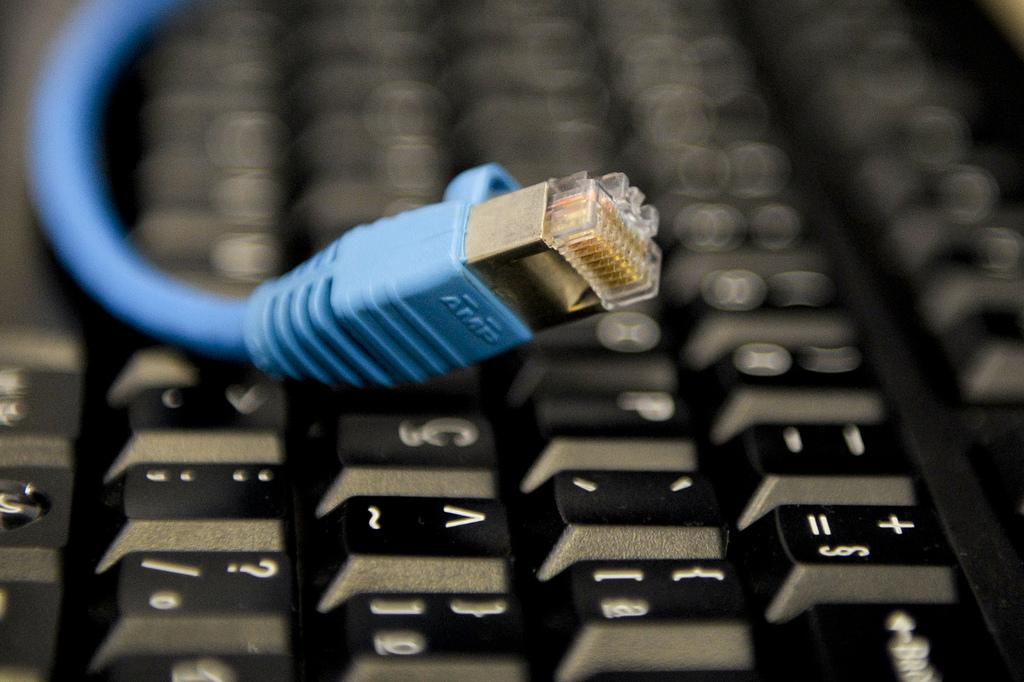<image>
Offer a succinct explanation of the picture presented. A blue cable on a keyboard with the word AMP visible. 